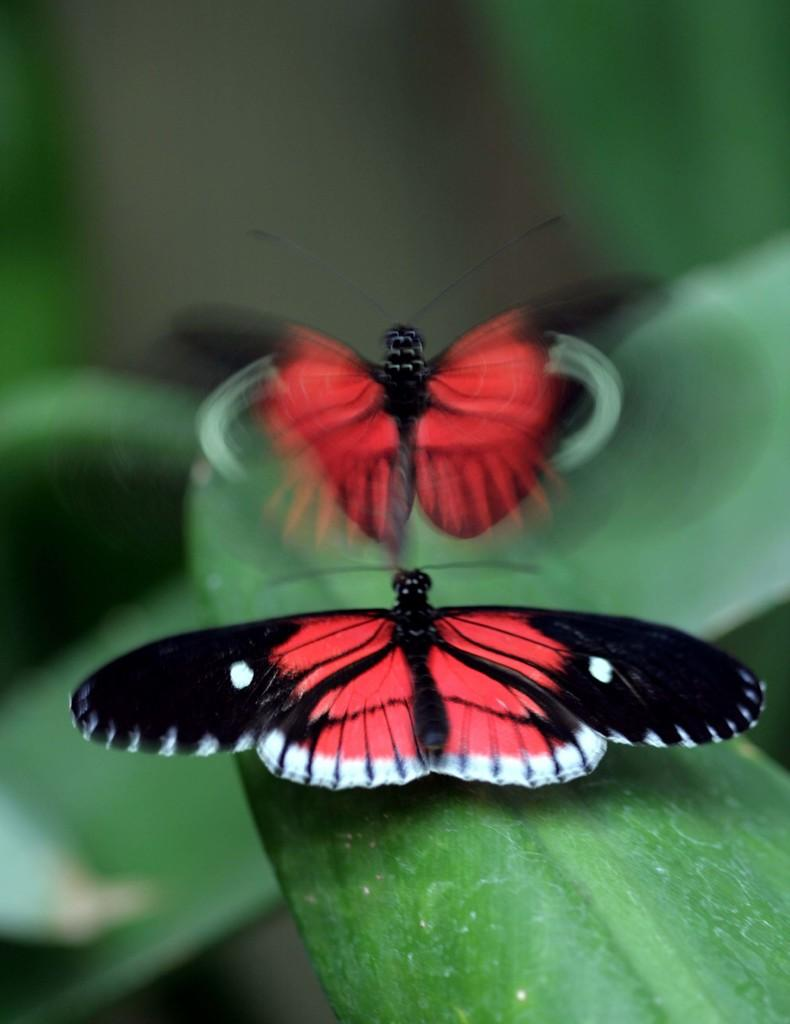How many butterflies are present in the image? There are two butterflies in the image. What is the position of one of the butterflies? One butterfly is on a leaf. What is the other butterfly doing in the image? The other butterfly is flying. What colors can be seen on the butterflies? The butterflies have black and red colors. Can you describe the background of the image? The background of the image is blurred. What type of passenger is the butterfly carrying on its back? Butterflies do not carry passengers, so there is no such activity depicted in the image. 